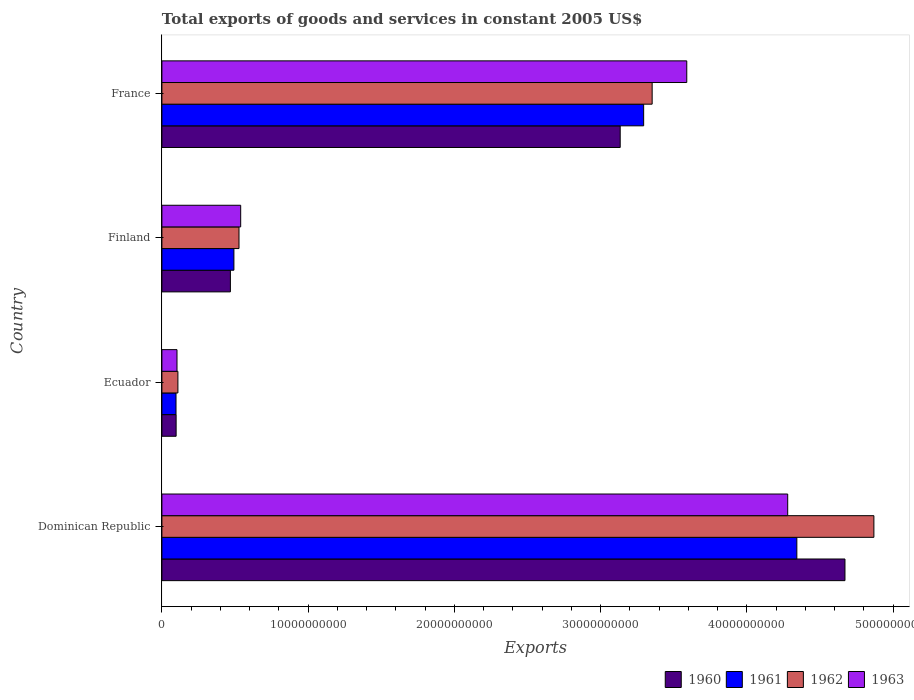Are the number of bars per tick equal to the number of legend labels?
Make the answer very short. Yes. Are the number of bars on each tick of the Y-axis equal?
Your answer should be very brief. Yes. How many bars are there on the 3rd tick from the bottom?
Your response must be concise. 4. What is the label of the 2nd group of bars from the top?
Ensure brevity in your answer.  Finland. In how many cases, is the number of bars for a given country not equal to the number of legend labels?
Your response must be concise. 0. What is the total exports of goods and services in 1962 in France?
Your answer should be very brief. 3.35e+1. Across all countries, what is the maximum total exports of goods and services in 1963?
Give a very brief answer. 4.28e+1. Across all countries, what is the minimum total exports of goods and services in 1962?
Keep it short and to the point. 1.09e+09. In which country was the total exports of goods and services in 1960 maximum?
Offer a very short reply. Dominican Republic. In which country was the total exports of goods and services in 1960 minimum?
Provide a succinct answer. Ecuador. What is the total total exports of goods and services in 1963 in the graph?
Keep it short and to the point. 8.51e+1. What is the difference between the total exports of goods and services in 1963 in Ecuador and that in Finland?
Your answer should be very brief. -4.36e+09. What is the difference between the total exports of goods and services in 1962 in Ecuador and the total exports of goods and services in 1960 in Finland?
Offer a very short reply. -3.59e+09. What is the average total exports of goods and services in 1963 per country?
Your answer should be very brief. 2.13e+1. What is the difference between the total exports of goods and services in 1963 and total exports of goods and services in 1960 in France?
Ensure brevity in your answer.  4.55e+09. What is the ratio of the total exports of goods and services in 1963 in Ecuador to that in France?
Provide a succinct answer. 0.03. Is the difference between the total exports of goods and services in 1963 in Ecuador and Finland greater than the difference between the total exports of goods and services in 1960 in Ecuador and Finland?
Keep it short and to the point. No. What is the difference between the highest and the second highest total exports of goods and services in 1960?
Offer a terse response. 1.54e+1. What is the difference between the highest and the lowest total exports of goods and services in 1960?
Give a very brief answer. 4.57e+1. In how many countries, is the total exports of goods and services in 1963 greater than the average total exports of goods and services in 1963 taken over all countries?
Your answer should be very brief. 2. Is it the case that in every country, the sum of the total exports of goods and services in 1963 and total exports of goods and services in 1962 is greater than the sum of total exports of goods and services in 1960 and total exports of goods and services in 1961?
Ensure brevity in your answer.  No. How many bars are there?
Ensure brevity in your answer.  16. How many countries are there in the graph?
Provide a succinct answer. 4. Does the graph contain any zero values?
Your response must be concise. No. How are the legend labels stacked?
Provide a short and direct response. Horizontal. What is the title of the graph?
Keep it short and to the point. Total exports of goods and services in constant 2005 US$. Does "1990" appear as one of the legend labels in the graph?
Your response must be concise. No. What is the label or title of the X-axis?
Your answer should be very brief. Exports. What is the label or title of the Y-axis?
Keep it short and to the point. Country. What is the Exports of 1960 in Dominican Republic?
Ensure brevity in your answer.  4.67e+1. What is the Exports in 1961 in Dominican Republic?
Offer a very short reply. 4.34e+1. What is the Exports in 1962 in Dominican Republic?
Keep it short and to the point. 4.87e+1. What is the Exports of 1963 in Dominican Republic?
Your answer should be very brief. 4.28e+1. What is the Exports of 1960 in Ecuador?
Give a very brief answer. 9.72e+08. What is the Exports of 1961 in Ecuador?
Keep it short and to the point. 9.65e+08. What is the Exports of 1962 in Ecuador?
Your answer should be compact. 1.09e+09. What is the Exports of 1963 in Ecuador?
Offer a very short reply. 1.03e+09. What is the Exports of 1960 in Finland?
Provide a short and direct response. 4.68e+09. What is the Exports in 1961 in Finland?
Make the answer very short. 4.92e+09. What is the Exports of 1962 in Finland?
Give a very brief answer. 5.27e+09. What is the Exports of 1963 in Finland?
Offer a very short reply. 5.39e+09. What is the Exports of 1960 in France?
Make the answer very short. 3.13e+1. What is the Exports of 1961 in France?
Make the answer very short. 3.29e+1. What is the Exports in 1962 in France?
Your answer should be compact. 3.35e+1. What is the Exports in 1963 in France?
Provide a short and direct response. 3.59e+1. Across all countries, what is the maximum Exports of 1960?
Give a very brief answer. 4.67e+1. Across all countries, what is the maximum Exports of 1961?
Give a very brief answer. 4.34e+1. Across all countries, what is the maximum Exports in 1962?
Provide a succinct answer. 4.87e+1. Across all countries, what is the maximum Exports of 1963?
Keep it short and to the point. 4.28e+1. Across all countries, what is the minimum Exports of 1960?
Give a very brief answer. 9.72e+08. Across all countries, what is the minimum Exports in 1961?
Give a very brief answer. 9.65e+08. Across all countries, what is the minimum Exports in 1962?
Give a very brief answer. 1.09e+09. Across all countries, what is the minimum Exports in 1963?
Your response must be concise. 1.03e+09. What is the total Exports in 1960 in the graph?
Make the answer very short. 8.37e+1. What is the total Exports of 1961 in the graph?
Offer a terse response. 8.22e+1. What is the total Exports of 1962 in the graph?
Provide a short and direct response. 8.86e+1. What is the total Exports of 1963 in the graph?
Provide a short and direct response. 8.51e+1. What is the difference between the Exports in 1960 in Dominican Republic and that in Ecuador?
Provide a succinct answer. 4.57e+1. What is the difference between the Exports of 1961 in Dominican Republic and that in Ecuador?
Your response must be concise. 4.25e+1. What is the difference between the Exports of 1962 in Dominican Republic and that in Ecuador?
Make the answer very short. 4.76e+1. What is the difference between the Exports of 1963 in Dominican Republic and that in Ecuador?
Your response must be concise. 4.18e+1. What is the difference between the Exports in 1960 in Dominican Republic and that in Finland?
Offer a very short reply. 4.20e+1. What is the difference between the Exports of 1961 in Dominican Republic and that in Finland?
Your answer should be compact. 3.85e+1. What is the difference between the Exports of 1962 in Dominican Republic and that in Finland?
Provide a short and direct response. 4.34e+1. What is the difference between the Exports of 1963 in Dominican Republic and that in Finland?
Your answer should be compact. 3.74e+1. What is the difference between the Exports of 1960 in Dominican Republic and that in France?
Offer a terse response. 1.54e+1. What is the difference between the Exports in 1961 in Dominican Republic and that in France?
Provide a short and direct response. 1.05e+1. What is the difference between the Exports of 1962 in Dominican Republic and that in France?
Keep it short and to the point. 1.52e+1. What is the difference between the Exports of 1963 in Dominican Republic and that in France?
Your answer should be very brief. 6.90e+09. What is the difference between the Exports in 1960 in Ecuador and that in Finland?
Your response must be concise. -3.71e+09. What is the difference between the Exports of 1961 in Ecuador and that in Finland?
Give a very brief answer. -3.96e+09. What is the difference between the Exports in 1962 in Ecuador and that in Finland?
Provide a short and direct response. -4.18e+09. What is the difference between the Exports of 1963 in Ecuador and that in Finland?
Offer a very short reply. -4.36e+09. What is the difference between the Exports in 1960 in Ecuador and that in France?
Offer a terse response. -3.04e+1. What is the difference between the Exports in 1961 in Ecuador and that in France?
Provide a succinct answer. -3.20e+1. What is the difference between the Exports in 1962 in Ecuador and that in France?
Provide a succinct answer. -3.24e+1. What is the difference between the Exports of 1963 in Ecuador and that in France?
Your answer should be very brief. -3.49e+1. What is the difference between the Exports in 1960 in Finland and that in France?
Your response must be concise. -2.67e+1. What is the difference between the Exports of 1961 in Finland and that in France?
Ensure brevity in your answer.  -2.80e+1. What is the difference between the Exports in 1962 in Finland and that in France?
Give a very brief answer. -2.83e+1. What is the difference between the Exports of 1963 in Finland and that in France?
Your answer should be very brief. -3.05e+1. What is the difference between the Exports of 1960 in Dominican Republic and the Exports of 1961 in Ecuador?
Offer a terse response. 4.57e+1. What is the difference between the Exports in 1960 in Dominican Republic and the Exports in 1962 in Ecuador?
Your response must be concise. 4.56e+1. What is the difference between the Exports of 1960 in Dominican Republic and the Exports of 1963 in Ecuador?
Your answer should be compact. 4.57e+1. What is the difference between the Exports of 1961 in Dominican Republic and the Exports of 1962 in Ecuador?
Provide a short and direct response. 4.23e+1. What is the difference between the Exports in 1961 in Dominican Republic and the Exports in 1963 in Ecuador?
Provide a short and direct response. 4.24e+1. What is the difference between the Exports of 1962 in Dominican Republic and the Exports of 1963 in Ecuador?
Your answer should be very brief. 4.77e+1. What is the difference between the Exports of 1960 in Dominican Republic and the Exports of 1961 in Finland?
Your answer should be very brief. 4.18e+1. What is the difference between the Exports in 1960 in Dominican Republic and the Exports in 1962 in Finland?
Provide a short and direct response. 4.14e+1. What is the difference between the Exports of 1960 in Dominican Republic and the Exports of 1963 in Finland?
Offer a terse response. 4.13e+1. What is the difference between the Exports of 1961 in Dominican Republic and the Exports of 1962 in Finland?
Your answer should be very brief. 3.81e+1. What is the difference between the Exports in 1961 in Dominican Republic and the Exports in 1963 in Finland?
Ensure brevity in your answer.  3.80e+1. What is the difference between the Exports in 1962 in Dominican Republic and the Exports in 1963 in Finland?
Give a very brief answer. 4.33e+1. What is the difference between the Exports of 1960 in Dominican Republic and the Exports of 1961 in France?
Keep it short and to the point. 1.38e+1. What is the difference between the Exports in 1960 in Dominican Republic and the Exports in 1962 in France?
Ensure brevity in your answer.  1.32e+1. What is the difference between the Exports of 1960 in Dominican Republic and the Exports of 1963 in France?
Make the answer very short. 1.08e+1. What is the difference between the Exports of 1961 in Dominican Republic and the Exports of 1962 in France?
Provide a short and direct response. 9.89e+09. What is the difference between the Exports in 1961 in Dominican Republic and the Exports in 1963 in France?
Your answer should be very brief. 7.53e+09. What is the difference between the Exports of 1962 in Dominican Republic and the Exports of 1963 in France?
Your answer should be compact. 1.28e+1. What is the difference between the Exports in 1960 in Ecuador and the Exports in 1961 in Finland?
Provide a short and direct response. -3.95e+09. What is the difference between the Exports in 1960 in Ecuador and the Exports in 1962 in Finland?
Provide a short and direct response. -4.30e+09. What is the difference between the Exports in 1960 in Ecuador and the Exports in 1963 in Finland?
Your answer should be compact. -4.41e+09. What is the difference between the Exports of 1961 in Ecuador and the Exports of 1962 in Finland?
Provide a succinct answer. -4.31e+09. What is the difference between the Exports of 1961 in Ecuador and the Exports of 1963 in Finland?
Your response must be concise. -4.42e+09. What is the difference between the Exports of 1962 in Ecuador and the Exports of 1963 in Finland?
Your answer should be compact. -4.29e+09. What is the difference between the Exports in 1960 in Ecuador and the Exports in 1961 in France?
Your answer should be compact. -3.20e+1. What is the difference between the Exports in 1960 in Ecuador and the Exports in 1962 in France?
Make the answer very short. -3.25e+1. What is the difference between the Exports of 1960 in Ecuador and the Exports of 1963 in France?
Make the answer very short. -3.49e+1. What is the difference between the Exports in 1961 in Ecuador and the Exports in 1962 in France?
Your answer should be compact. -3.26e+1. What is the difference between the Exports in 1961 in Ecuador and the Exports in 1963 in France?
Your answer should be compact. -3.49e+1. What is the difference between the Exports of 1962 in Ecuador and the Exports of 1963 in France?
Ensure brevity in your answer.  -3.48e+1. What is the difference between the Exports of 1960 in Finland and the Exports of 1961 in France?
Keep it short and to the point. -2.83e+1. What is the difference between the Exports of 1960 in Finland and the Exports of 1962 in France?
Offer a terse response. -2.88e+1. What is the difference between the Exports in 1960 in Finland and the Exports in 1963 in France?
Offer a very short reply. -3.12e+1. What is the difference between the Exports in 1961 in Finland and the Exports in 1962 in France?
Make the answer very short. -2.86e+1. What is the difference between the Exports of 1961 in Finland and the Exports of 1963 in France?
Your response must be concise. -3.10e+1. What is the difference between the Exports in 1962 in Finland and the Exports in 1963 in France?
Offer a terse response. -3.06e+1. What is the average Exports of 1960 per country?
Your answer should be compact. 2.09e+1. What is the average Exports of 1961 per country?
Give a very brief answer. 2.06e+1. What is the average Exports of 1962 per country?
Offer a terse response. 2.21e+1. What is the average Exports in 1963 per country?
Ensure brevity in your answer.  2.13e+1. What is the difference between the Exports in 1960 and Exports in 1961 in Dominican Republic?
Give a very brief answer. 3.29e+09. What is the difference between the Exports in 1960 and Exports in 1962 in Dominican Republic?
Give a very brief answer. -1.98e+09. What is the difference between the Exports in 1960 and Exports in 1963 in Dominican Republic?
Keep it short and to the point. 3.92e+09. What is the difference between the Exports of 1961 and Exports of 1962 in Dominican Republic?
Your response must be concise. -5.27e+09. What is the difference between the Exports of 1961 and Exports of 1963 in Dominican Republic?
Your answer should be compact. 6.26e+08. What is the difference between the Exports of 1962 and Exports of 1963 in Dominican Republic?
Give a very brief answer. 5.89e+09. What is the difference between the Exports in 1960 and Exports in 1961 in Ecuador?
Keep it short and to the point. 7.18e+06. What is the difference between the Exports in 1960 and Exports in 1962 in Ecuador?
Keep it short and to the point. -1.22e+08. What is the difference between the Exports in 1960 and Exports in 1963 in Ecuador?
Your answer should be compact. -5.99e+07. What is the difference between the Exports in 1961 and Exports in 1962 in Ecuador?
Keep it short and to the point. -1.29e+08. What is the difference between the Exports in 1961 and Exports in 1963 in Ecuador?
Ensure brevity in your answer.  -6.70e+07. What is the difference between the Exports in 1962 and Exports in 1963 in Ecuador?
Your answer should be very brief. 6.23e+07. What is the difference between the Exports of 1960 and Exports of 1961 in Finland?
Keep it short and to the point. -2.41e+08. What is the difference between the Exports of 1960 and Exports of 1962 in Finland?
Offer a very short reply. -5.89e+08. What is the difference between the Exports of 1960 and Exports of 1963 in Finland?
Give a very brief answer. -7.04e+08. What is the difference between the Exports of 1961 and Exports of 1962 in Finland?
Offer a terse response. -3.48e+08. What is the difference between the Exports of 1961 and Exports of 1963 in Finland?
Your answer should be very brief. -4.64e+08. What is the difference between the Exports in 1962 and Exports in 1963 in Finland?
Ensure brevity in your answer.  -1.15e+08. What is the difference between the Exports in 1960 and Exports in 1961 in France?
Your answer should be very brief. -1.60e+09. What is the difference between the Exports of 1960 and Exports of 1962 in France?
Your answer should be very brief. -2.19e+09. What is the difference between the Exports of 1960 and Exports of 1963 in France?
Make the answer very short. -4.55e+09. What is the difference between the Exports in 1961 and Exports in 1962 in France?
Make the answer very short. -5.82e+08. What is the difference between the Exports in 1961 and Exports in 1963 in France?
Your response must be concise. -2.95e+09. What is the difference between the Exports in 1962 and Exports in 1963 in France?
Offer a very short reply. -2.37e+09. What is the ratio of the Exports in 1960 in Dominican Republic to that in Ecuador?
Ensure brevity in your answer.  48.04. What is the ratio of the Exports in 1961 in Dominican Republic to that in Ecuador?
Make the answer very short. 44.99. What is the ratio of the Exports in 1962 in Dominican Republic to that in Ecuador?
Your answer should be compact. 44.49. What is the ratio of the Exports in 1963 in Dominican Republic to that in Ecuador?
Give a very brief answer. 41.46. What is the ratio of the Exports of 1960 in Dominican Republic to that in Finland?
Keep it short and to the point. 9.97. What is the ratio of the Exports of 1961 in Dominican Republic to that in Finland?
Provide a short and direct response. 8.82. What is the ratio of the Exports in 1962 in Dominican Republic to that in Finland?
Make the answer very short. 9.23. What is the ratio of the Exports in 1963 in Dominican Republic to that in Finland?
Provide a succinct answer. 7.94. What is the ratio of the Exports of 1960 in Dominican Republic to that in France?
Your answer should be very brief. 1.49. What is the ratio of the Exports in 1961 in Dominican Republic to that in France?
Ensure brevity in your answer.  1.32. What is the ratio of the Exports in 1962 in Dominican Republic to that in France?
Offer a terse response. 1.45. What is the ratio of the Exports of 1963 in Dominican Republic to that in France?
Your response must be concise. 1.19. What is the ratio of the Exports in 1960 in Ecuador to that in Finland?
Make the answer very short. 0.21. What is the ratio of the Exports in 1961 in Ecuador to that in Finland?
Your response must be concise. 0.2. What is the ratio of the Exports of 1962 in Ecuador to that in Finland?
Your answer should be compact. 0.21. What is the ratio of the Exports in 1963 in Ecuador to that in Finland?
Make the answer very short. 0.19. What is the ratio of the Exports in 1960 in Ecuador to that in France?
Keep it short and to the point. 0.03. What is the ratio of the Exports of 1961 in Ecuador to that in France?
Your answer should be very brief. 0.03. What is the ratio of the Exports of 1962 in Ecuador to that in France?
Keep it short and to the point. 0.03. What is the ratio of the Exports in 1963 in Ecuador to that in France?
Your answer should be very brief. 0.03. What is the ratio of the Exports in 1960 in Finland to that in France?
Your answer should be very brief. 0.15. What is the ratio of the Exports in 1961 in Finland to that in France?
Give a very brief answer. 0.15. What is the ratio of the Exports in 1962 in Finland to that in France?
Give a very brief answer. 0.16. What is the ratio of the Exports in 1963 in Finland to that in France?
Your answer should be very brief. 0.15. What is the difference between the highest and the second highest Exports in 1960?
Your answer should be compact. 1.54e+1. What is the difference between the highest and the second highest Exports in 1961?
Provide a short and direct response. 1.05e+1. What is the difference between the highest and the second highest Exports of 1962?
Provide a short and direct response. 1.52e+1. What is the difference between the highest and the second highest Exports of 1963?
Offer a terse response. 6.90e+09. What is the difference between the highest and the lowest Exports in 1960?
Make the answer very short. 4.57e+1. What is the difference between the highest and the lowest Exports in 1961?
Give a very brief answer. 4.25e+1. What is the difference between the highest and the lowest Exports in 1962?
Ensure brevity in your answer.  4.76e+1. What is the difference between the highest and the lowest Exports of 1963?
Keep it short and to the point. 4.18e+1. 